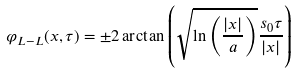<formula> <loc_0><loc_0><loc_500><loc_500>\varphi _ { L - L } ( x , \tau ) = \pm 2 \arctan \left ( \sqrt { \ln \left ( \frac { | x | } { a } \right ) } \frac { s _ { 0 } \tau } { | x | } \right )</formula> 